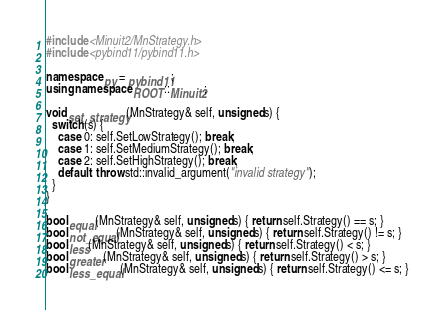Convert code to text. <code><loc_0><loc_0><loc_500><loc_500><_C++_>#include <Minuit2/MnStrategy.h>
#include <pybind11/pybind11.h>

namespace py = pybind11;
using namespace ROOT::Minuit2;

void set_strategy(MnStrategy& self, unsigned s) {
  switch (s) {
    case 0: self.SetLowStrategy(); break;
    case 1: self.SetMediumStrategy(); break;
    case 2: self.SetHighStrategy(); break;
    default: throw std::invalid_argument("invalid strategy");
  }
}

bool equal(MnStrategy& self, unsigned s) { return self.Strategy() == s; }
bool not_equal(MnStrategy& self, unsigned s) { return self.Strategy() != s; }
bool less(MnStrategy& self, unsigned s) { return self.Strategy() < s; }
bool greater(MnStrategy& self, unsigned s) { return self.Strategy() > s; }
bool less_equal(MnStrategy& self, unsigned s) { return self.Strategy() <= s; }</code> 